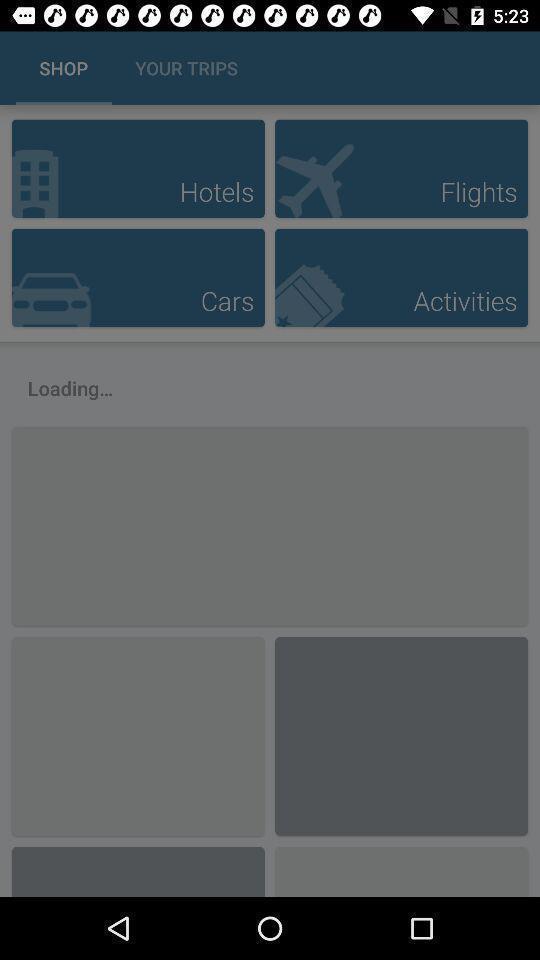Provide a description of this screenshot. Page that displaying travels application. 